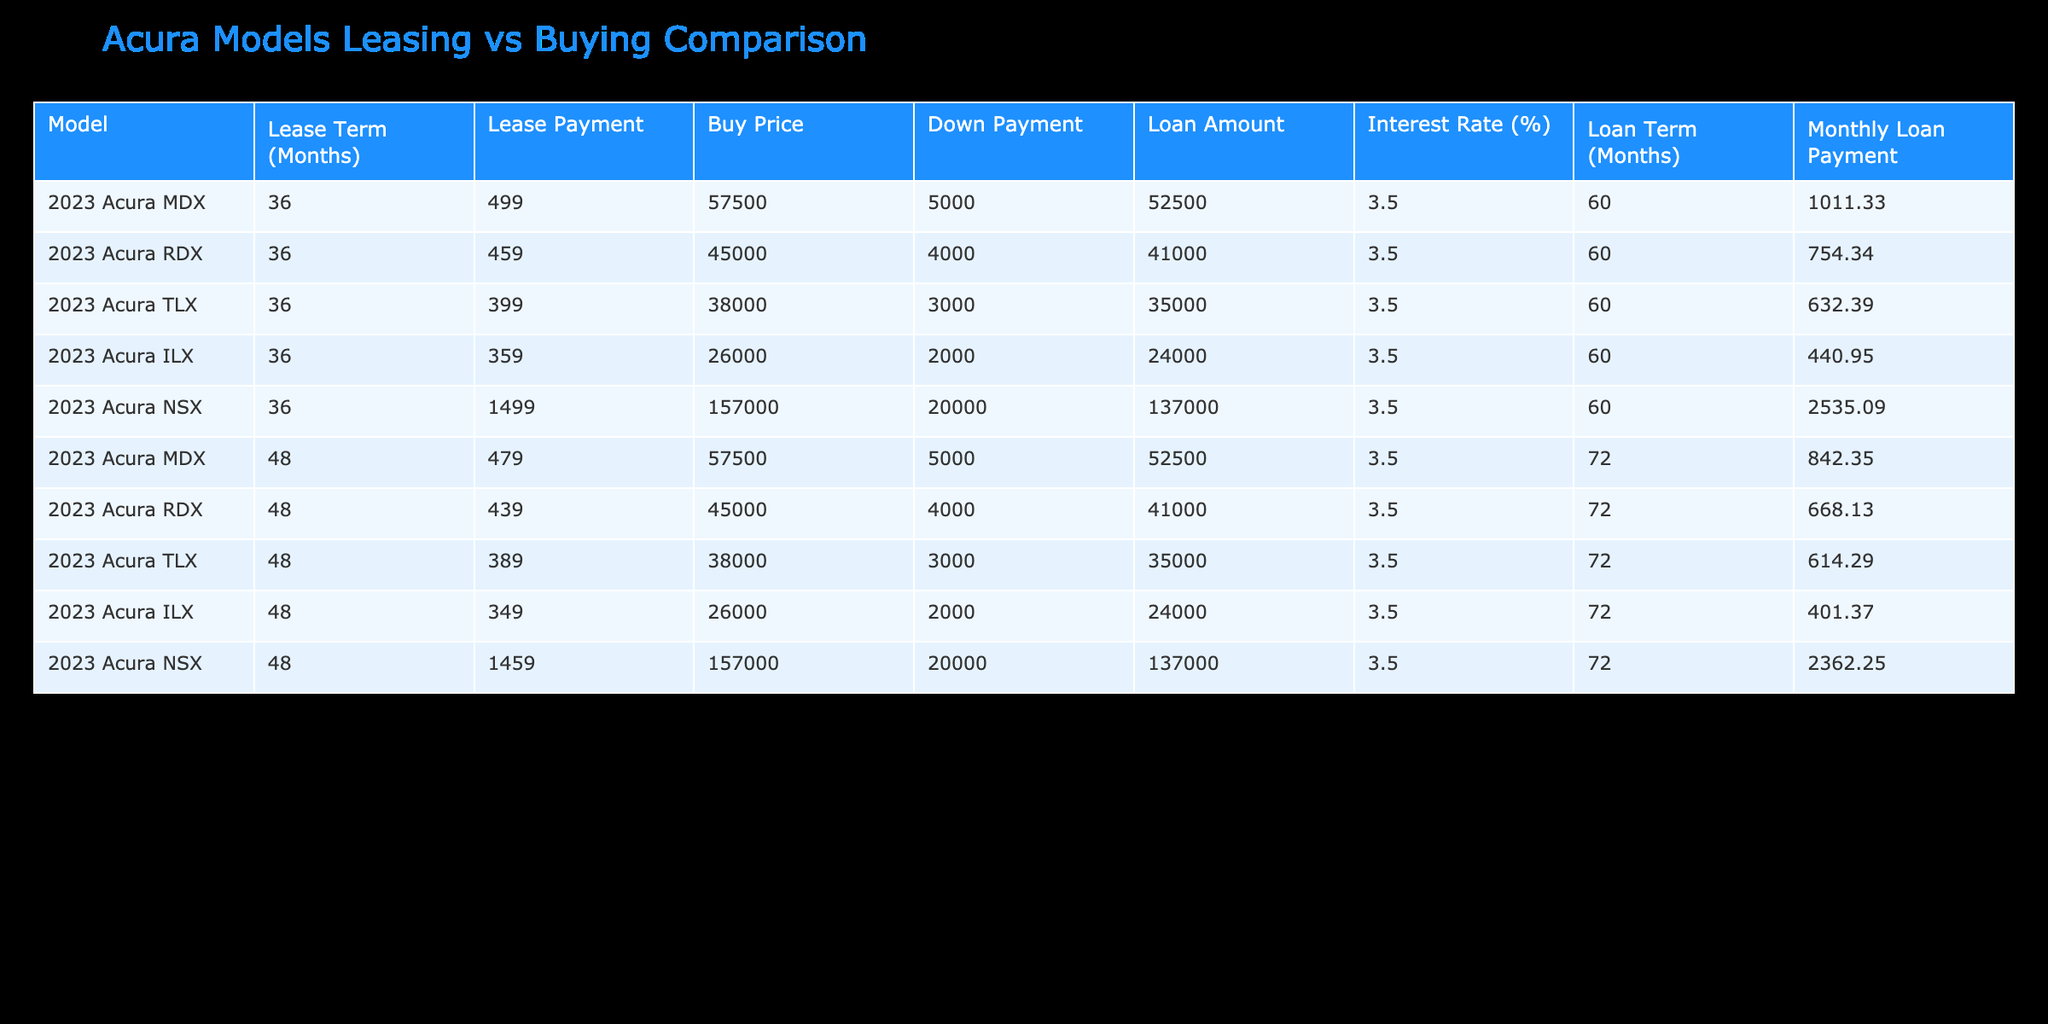What is the monthly lease payment for the 2023 Acura MDX with a 36-month term? The table indicates that the monthly lease payment for the 2023 Acura MDX over a 36-month term is listed directly under the Lease Payment column. Looking at that row, I see the value is 499.
Answer: 499 What is the total loan amount for the 2023 Acura NSX when purchased? The table shows the buy price of the 2023 Acura NSX is 157000, and the down payment is 20000. To find the loan amount, subtract the down payment from the buy price: 157000 - 20000 = 137000.
Answer: 137000 Is the monthly lease payment for the 2023 Acura RDX higher or lower than that for the 2023 Acura TLX? The monthly lease payment for the 2023 Acura RDX is 459, while the payment for the 2023 Acura TLX is 399. Since 459 is greater than 399, the payment for the RDX is higher.
Answer: Higher What is the average monthly loan payment across all Acura models listed in the table? To find the average monthly loan payment, I need to sum up all the loan payments and divide by the total number of models. The monthly loan payments are: 1011.33, 754.34, 632.39, 440.95, 2535.09, 842.35, 668.13, 614.29, 401.37, and 2362.25. The total is 1011.33 + 754.34 + 632.39 + 440.95 + 2535.09 + 842.35 + 668.13 + 614.29 + 401.37 + 2362.25 = 10364.4. There are 10 payments, so the average is 10364.4 / 10 = 1036.44.
Answer: 1036.44 Which Acura model has the lowest monthly loan payment if purchased? To determine this, compare the monthly loan payments listed in the table: 1011.33 (MDX), 754.34 (RDX), 632.39 (TLX), 440.95 (ILX), 2535.09 (NSX), 842.35 (MDX with 48 months), 668.13 (RDX with 48 months), 614.29 (TLX with 48 months), 401.37 (ILX with 48 months), and 2362.25 (NSX with 48 months). Among these, 401.37 for the 2023 Acura ILX with a 48-month term is the lowest.
Answer: 2023 Acura ILX 